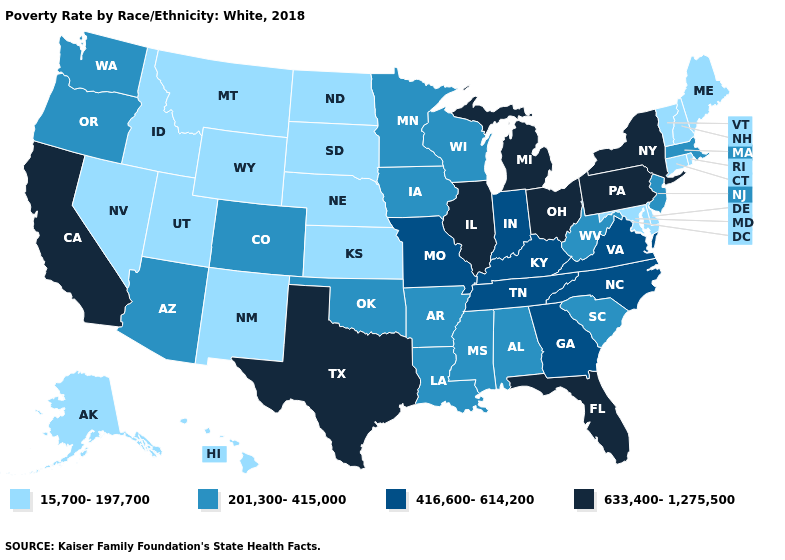What is the value of Iowa?
Give a very brief answer. 201,300-415,000. What is the value of Rhode Island?
Keep it brief. 15,700-197,700. Name the states that have a value in the range 15,700-197,700?
Concise answer only. Alaska, Connecticut, Delaware, Hawaii, Idaho, Kansas, Maine, Maryland, Montana, Nebraska, Nevada, New Hampshire, New Mexico, North Dakota, Rhode Island, South Dakota, Utah, Vermont, Wyoming. Name the states that have a value in the range 201,300-415,000?
Concise answer only. Alabama, Arizona, Arkansas, Colorado, Iowa, Louisiana, Massachusetts, Minnesota, Mississippi, New Jersey, Oklahoma, Oregon, South Carolina, Washington, West Virginia, Wisconsin. Name the states that have a value in the range 201,300-415,000?
Keep it brief. Alabama, Arizona, Arkansas, Colorado, Iowa, Louisiana, Massachusetts, Minnesota, Mississippi, New Jersey, Oklahoma, Oregon, South Carolina, Washington, West Virginia, Wisconsin. Name the states that have a value in the range 201,300-415,000?
Quick response, please. Alabama, Arizona, Arkansas, Colorado, Iowa, Louisiana, Massachusetts, Minnesota, Mississippi, New Jersey, Oklahoma, Oregon, South Carolina, Washington, West Virginia, Wisconsin. What is the value of Illinois?
Be succinct. 633,400-1,275,500. What is the lowest value in the USA?
Be succinct. 15,700-197,700. What is the lowest value in the MidWest?
Be succinct. 15,700-197,700. Among the states that border Indiana , does Kentucky have the highest value?
Short answer required. No. What is the highest value in the MidWest ?
Be succinct. 633,400-1,275,500. What is the value of Vermont?
Quick response, please. 15,700-197,700. Name the states that have a value in the range 416,600-614,200?
Give a very brief answer. Georgia, Indiana, Kentucky, Missouri, North Carolina, Tennessee, Virginia. Which states have the lowest value in the MidWest?
Concise answer only. Kansas, Nebraska, North Dakota, South Dakota. Does California have the highest value in the West?
Short answer required. Yes. 